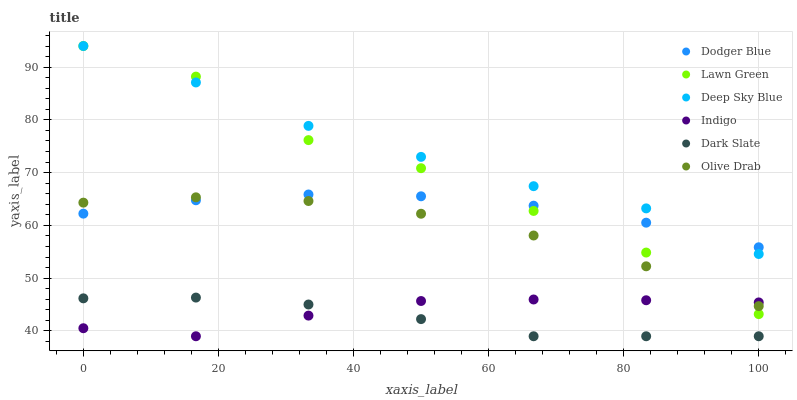Does Dark Slate have the minimum area under the curve?
Answer yes or no. Yes. Does Deep Sky Blue have the maximum area under the curve?
Answer yes or no. Yes. Does Indigo have the minimum area under the curve?
Answer yes or no. No. Does Indigo have the maximum area under the curve?
Answer yes or no. No. Is Dark Slate the smoothest?
Answer yes or no. Yes. Is Lawn Green the roughest?
Answer yes or no. Yes. Is Indigo the smoothest?
Answer yes or no. No. Is Indigo the roughest?
Answer yes or no. No. Does Indigo have the lowest value?
Answer yes or no. Yes. Does Dodger Blue have the lowest value?
Answer yes or no. No. Does Deep Sky Blue have the highest value?
Answer yes or no. Yes. Does Dark Slate have the highest value?
Answer yes or no. No. Is Dark Slate less than Olive Drab?
Answer yes or no. Yes. Is Dodger Blue greater than Indigo?
Answer yes or no. Yes. Does Olive Drab intersect Lawn Green?
Answer yes or no. Yes. Is Olive Drab less than Lawn Green?
Answer yes or no. No. Is Olive Drab greater than Lawn Green?
Answer yes or no. No. Does Dark Slate intersect Olive Drab?
Answer yes or no. No. 